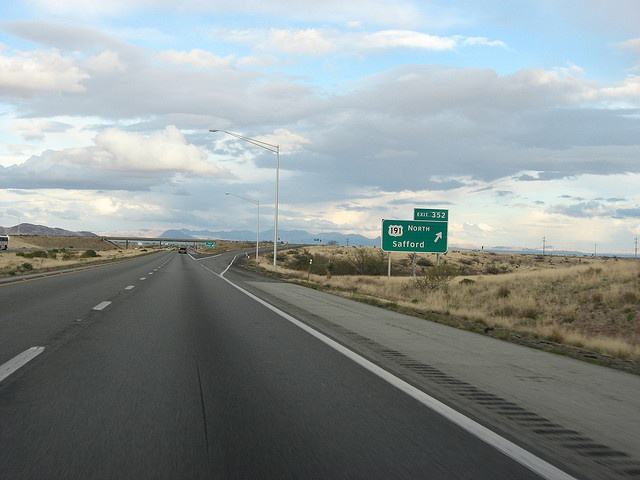Describe the objects in this image and their specific colors. I can see a car in lightblue, gray, black, and purple tones in this image. 